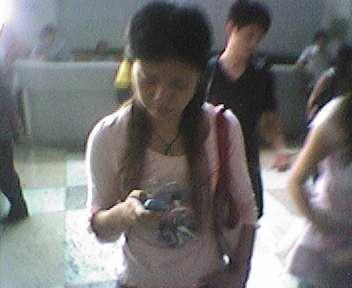How many people are there?
Give a very brief answer. 4. How many red chairs are there?
Give a very brief answer. 0. 